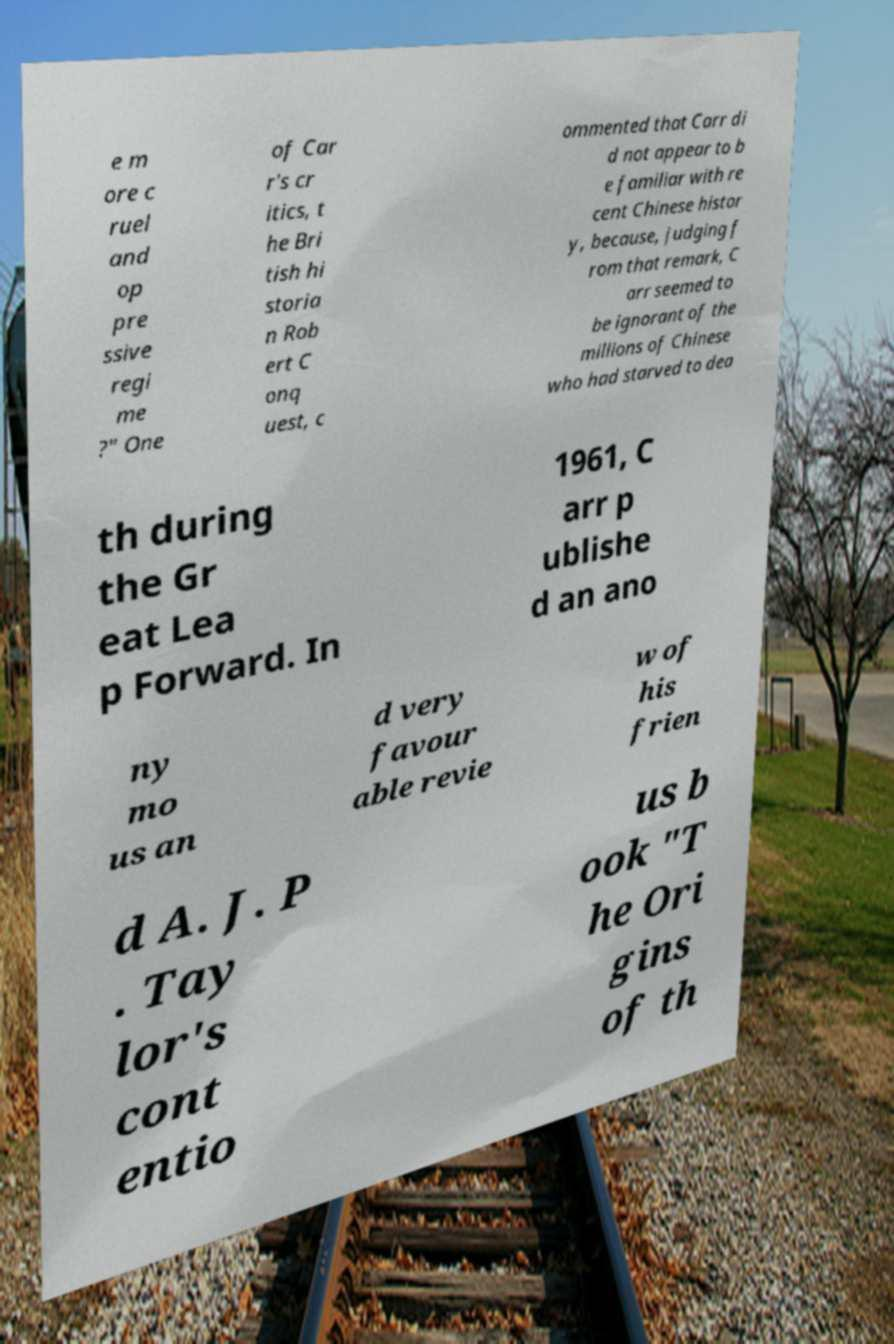Could you assist in decoding the text presented in this image and type it out clearly? e m ore c ruel and op pre ssive regi me ?" One of Car r's cr itics, t he Bri tish hi storia n Rob ert C onq uest, c ommented that Carr di d not appear to b e familiar with re cent Chinese histor y, because, judging f rom that remark, C arr seemed to be ignorant of the millions of Chinese who had starved to dea th during the Gr eat Lea p Forward. In 1961, C arr p ublishe d an ano ny mo us an d very favour able revie w of his frien d A. J. P . Tay lor's cont entio us b ook "T he Ori gins of th 